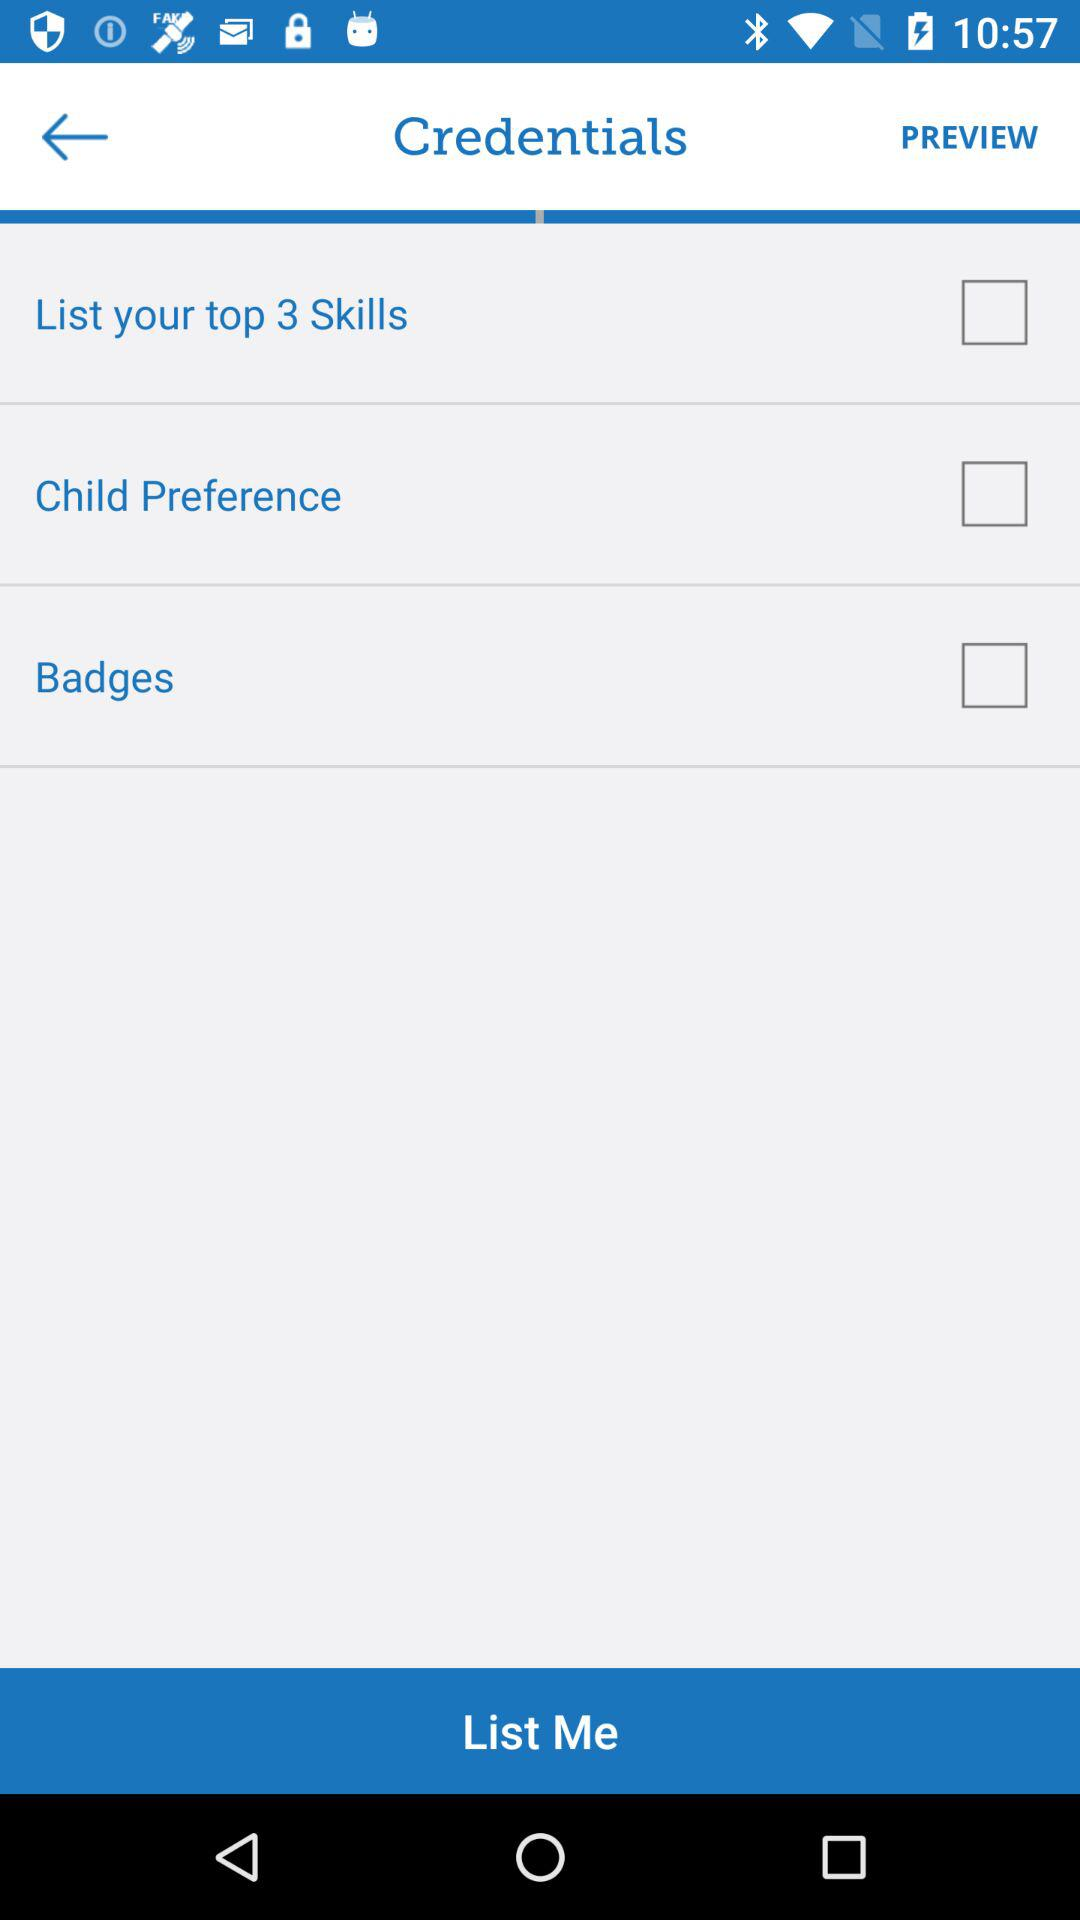What are the given options that can be checked? The options are "List your top 3 Skills", "Child Preference" and "Badges". 